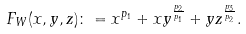<formula> <loc_0><loc_0><loc_500><loc_500>F _ { W } ( x , y , z ) \colon = x ^ { p _ { 1 } } + x y ^ { \frac { p _ { 2 } } { p _ { 1 } } } + y z ^ { \frac { p _ { 3 } } { p _ { 2 } } } .</formula> 